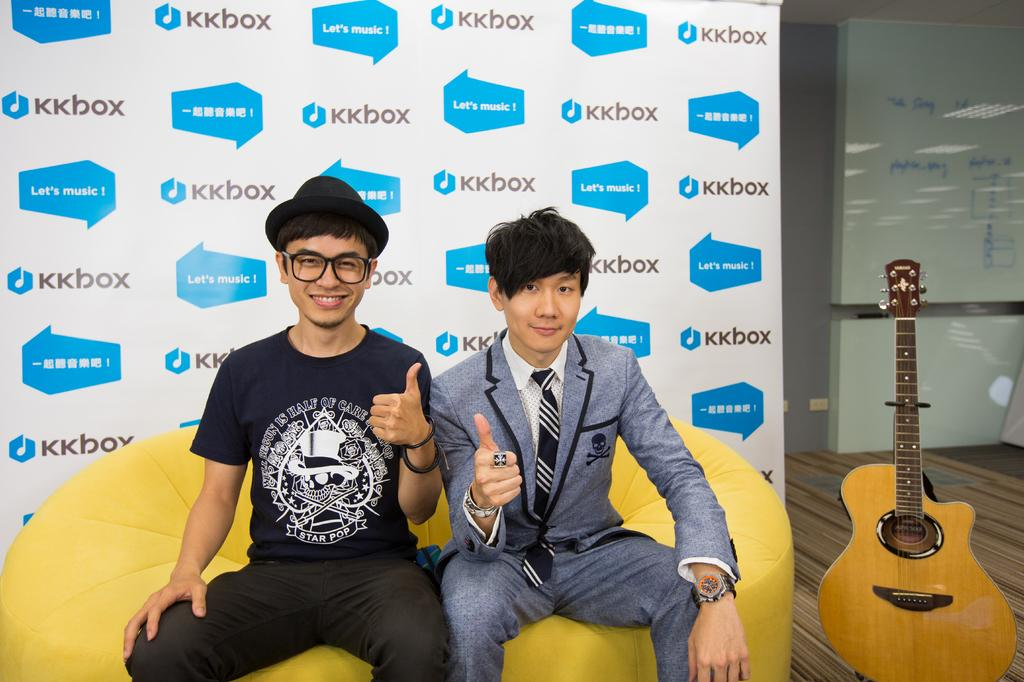How many people are in the image? There are two men in the image. What are the men sitting on? The men are sitting on yellow chairs. What object can be seen on the floor in the image? There is a guitar on the floor in the image. What color is the hydrant next to the guitar in the image? There is no hydrant present in the image. Can you see a swing in the image? No, there is no swing present in the image. 